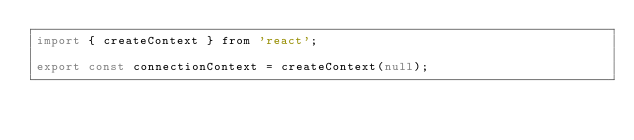<code> <loc_0><loc_0><loc_500><loc_500><_JavaScript_>import { createContext } from 'react';

export const connectionContext = createContext(null);
</code> 